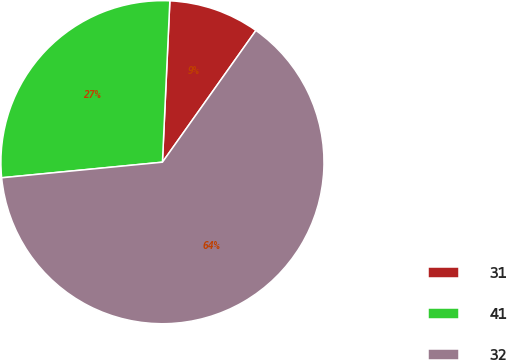<chart> <loc_0><loc_0><loc_500><loc_500><pie_chart><fcel>31<fcel>41<fcel>32<nl><fcel>9.09%<fcel>27.27%<fcel>63.64%<nl></chart> 